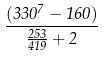Convert formula to latex. <formula><loc_0><loc_0><loc_500><loc_500>\frac { ( 3 3 0 ^ { 7 } - 1 6 0 ) } { \frac { 2 5 3 } { 4 1 9 } + 2 }</formula> 